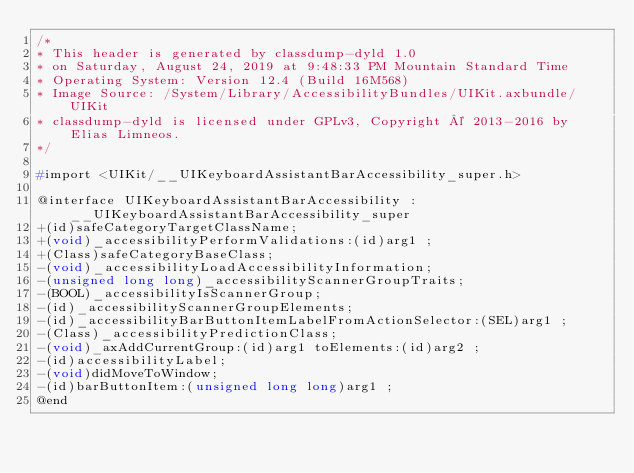<code> <loc_0><loc_0><loc_500><loc_500><_C_>/*
* This header is generated by classdump-dyld 1.0
* on Saturday, August 24, 2019 at 9:48:33 PM Mountain Standard Time
* Operating System: Version 12.4 (Build 16M568)
* Image Source: /System/Library/AccessibilityBundles/UIKit.axbundle/UIKit
* classdump-dyld is licensed under GPLv3, Copyright © 2013-2016 by Elias Limneos.
*/

#import <UIKit/__UIKeyboardAssistantBarAccessibility_super.h>

@interface UIKeyboardAssistantBarAccessibility : __UIKeyboardAssistantBarAccessibility_super
+(id)safeCategoryTargetClassName;
+(void)_accessibilityPerformValidations:(id)arg1 ;
+(Class)safeCategoryBaseClass;
-(void)_accessibilityLoadAccessibilityInformation;
-(unsigned long long)_accessibilityScannerGroupTraits;
-(BOOL)_accessibilityIsScannerGroup;
-(id)_accessibilityScannerGroupElements;
-(id)_accessibilityBarButtonItemLabelFromActionSelector:(SEL)arg1 ;
-(Class)_accessibilityPredictionClass;
-(void)_axAddCurrentGroup:(id)arg1 toElements:(id)arg2 ;
-(id)accessibilityLabel;
-(void)didMoveToWindow;
-(id)barButtonItem:(unsigned long long)arg1 ;
@end

</code> 